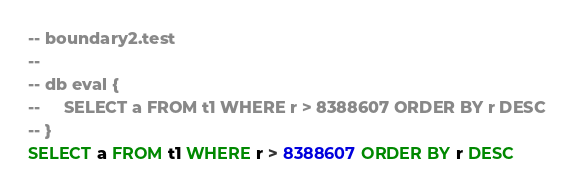<code> <loc_0><loc_0><loc_500><loc_500><_SQL_>-- boundary2.test
-- 
-- db eval {
--     SELECT a FROM t1 WHERE r > 8388607 ORDER BY r DESC
-- }
SELECT a FROM t1 WHERE r > 8388607 ORDER BY r DESC</code> 